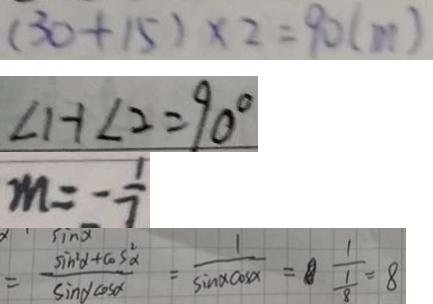Convert formula to latex. <formula><loc_0><loc_0><loc_500><loc_500>( 3 0 + 1 5 ) \times 2 = 9 0 ( m ) 
 \angle H \angle 2 = 9 0 ^ { \circ } 
 m = - \frac { 1 } { 7 } 
 \sin a = \frac { \sin \alpha + \cos ^ { 2 } \alpha } { \sin \alpha \cos \alpha } = \frac { 1 } { \sin \alpha \cos \alpha } = \frac { 1 } { \frac { 1 } { 8 } } = 8</formula> 